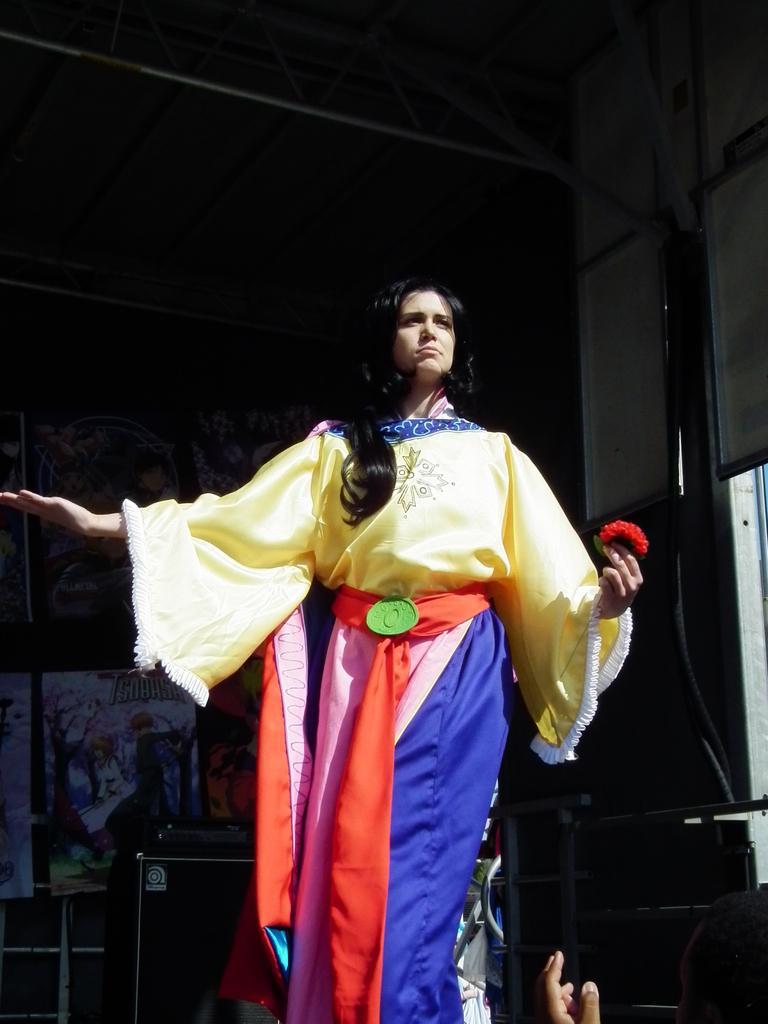Please provide a concise description of this image. In this picture there is a woman standing and holding the flower. At the back there are boards and there is painting on the boards and there is a pipe on the wall and there is a speaker and there is a railing. At the bottom right there is a person. 